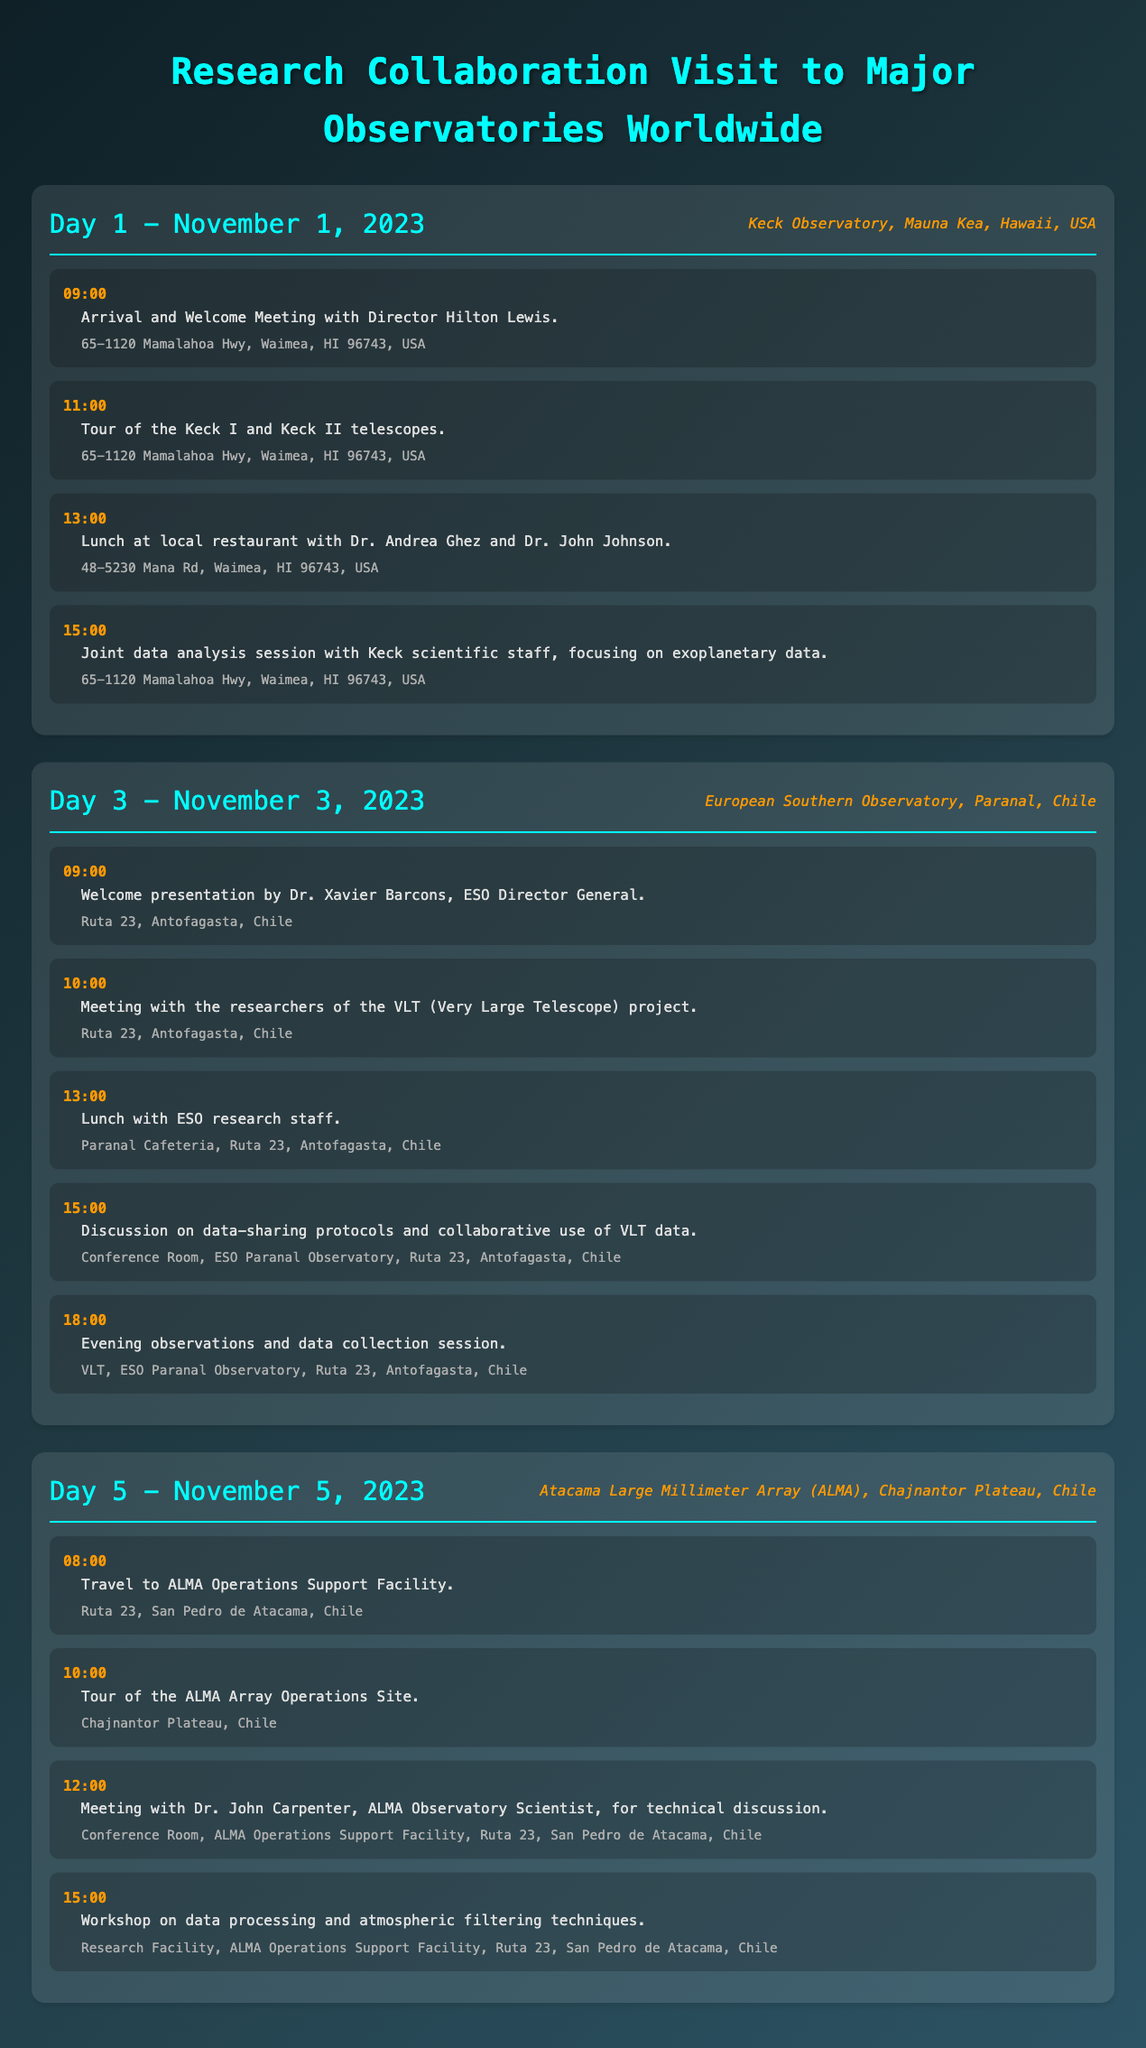What is the date of the visit to the Keck Observatory? The visit to the Keck Observatory takes place on Day 1, which is November 1, 2023.
Answer: November 1, 2023 Who is the Director of the Keck Observatory? The Director of the Keck Observatory is Hilton Lewis, who is mentioned in the welcome meeting.
Answer: Hilton Lewis What is discussed during the joint data analysis session? The joint data analysis session focuses on exoplanetary data.
Answer: Exoplanetary data What time does the welcome presentation at the European Southern Observatory start? The welcome presentation is scheduled to start at 09:00 on Day 3.
Answer: 09:00 Which observatory is being visited on Day 5? The observatory being visited on Day 5 is the Atacama Large Millimeter Array (ALMA).
Answer: Atacama Large Millimeter Array (ALMA) What type of workshop is held on Day 5 at ALMA? The workshop on Day 5 is focused on data processing and atmospheric filtering techniques.
Answer: Data processing and atmospheric filtering techniques What is the location of the ALMA Operations Support Facility? The ALMA Operations Support Facility is located on Ruta 23, San Pedro de Atacama, Chile.
Answer: Ruta 23, San Pedro de Atacama, Chile Who is leading the meeting for technical discussion at ALMA? The meeting for technical discussion at ALMA is led by Dr. John Carpenter.
Answer: Dr. John Carpenter 